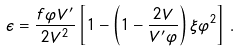<formula> <loc_0><loc_0><loc_500><loc_500>\epsilon = \frac { f \varphi V ^ { \prime } } { 2 V ^ { 2 } } \left [ 1 - \left ( 1 - \frac { 2 V } { V ^ { \prime } \varphi } \right ) \xi \varphi ^ { 2 } \right ] \, .</formula> 